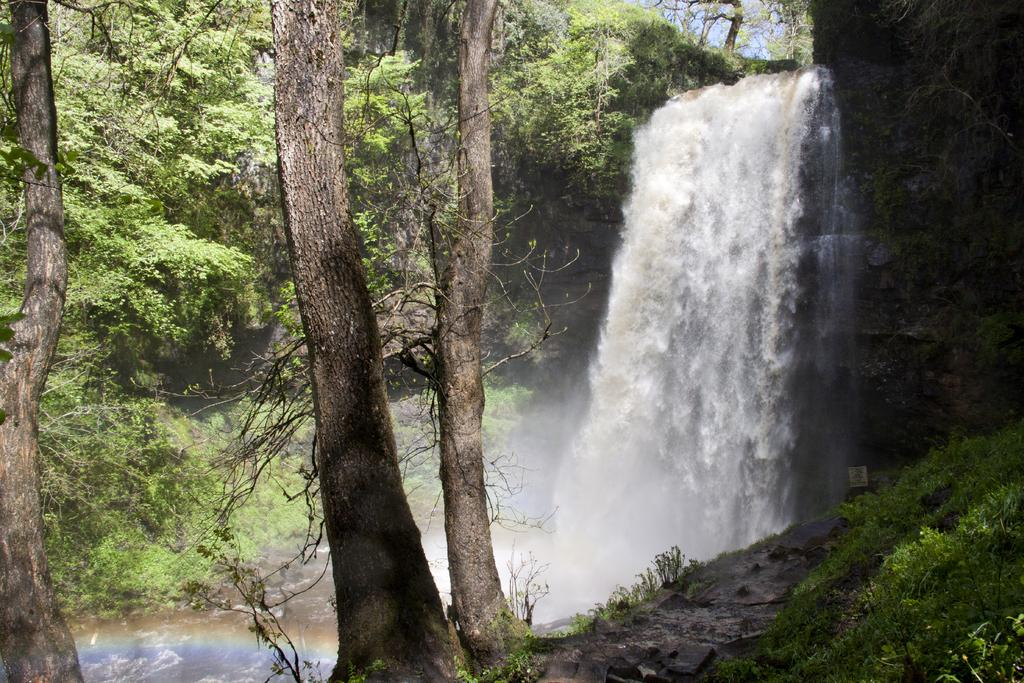What natural feature is the main subject of the picture? There is a waterfall in the picture. How is the waterfall described? The waterfall is described as beautiful. What type of vegetation is present around the waterfall? There are many trees around the waterfall. What is the reason for the hospital being built near the waterfall in the image? There is no hospital present in the image; it only features a beautiful waterfall surrounded by trees. 